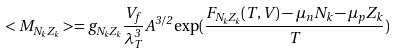<formula> <loc_0><loc_0><loc_500><loc_500>< M _ { N _ { k } Z _ { k } } > = g _ { N _ { k } Z _ { k } } \frac { V _ { f } } { \lambda _ { T } ^ { 3 } } A ^ { 3 / 2 } \exp ( \frac { F _ { N _ { k } Z _ { k } } ( T , V ) - \mu _ { n } N _ { k } - \mu _ { p } Z _ { k } } { T } )</formula> 